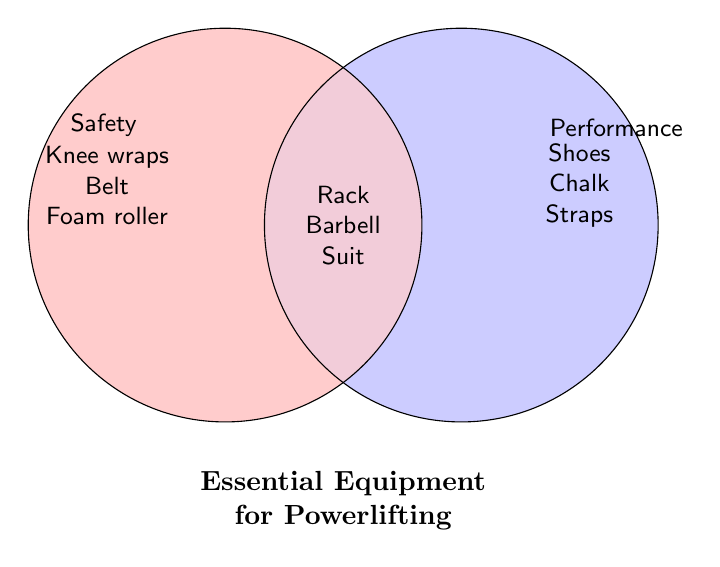Which equipment is essential for both safety and performance? Look for the section where the two circles overlap. The equipment listed there includes the Power rack, Barbell, and Squat suit.
Answer: Power rack, Barbell, Squat suit What is the title of the Venn Diagram? The title is typically placed prominently at the bottom or top of the diagram. In this case, it's at the bottom.
Answer: Essential Equipment for Powerlifting Name two items that are essential for safety only. Look inside the left circle, which represents safety equipment. Two of the items listed are Knee wraps and a Weightlifting belt.
Answer: Knee wraps, Weightlifting belt Which equipment listed is solely for performance improvement? Refer to the right circle, which represents performance equipment. Items there include Lifting shoes and Chalk.
Answer: Lifting shoes, Chalk How many items are listed under safety and performance combined? Count all the unique items from the three sections of the Venn Diagram (Safety, Performance, and Both).
Answer: Nine Which category contains the most items? Compare the number of items in each section. Both the Safety and Performance sections have five items each, while Both has three.
Answer: Safety and Performance What equipment for performance can also improve grip strength? Identify equipment related to grip strength from the Performance section. Grip strengtheners are listed there.
Answer: Grip strengtheners Is the Squat suit listed under safety, performance, or both? Check where the Squat suit appears in the Venn Diagram. It's located in the overlapping section.
Answer: Both 